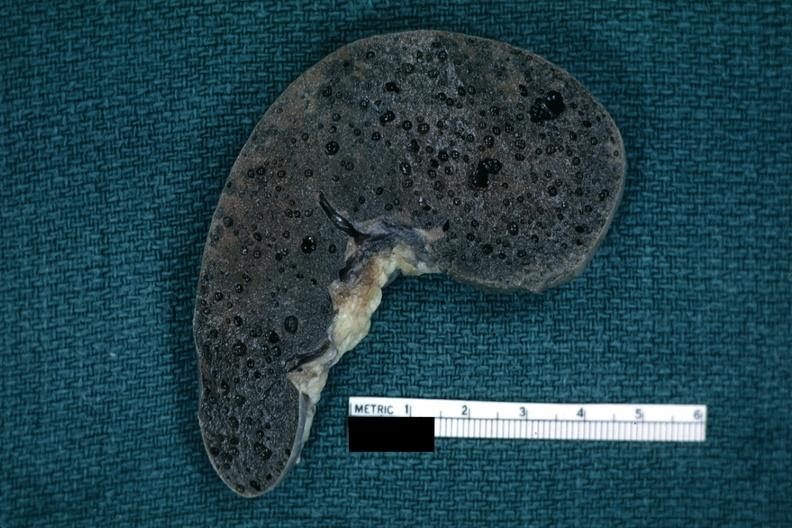s stillborn cord around neck present?
Answer the question using a single word or phrase. No 